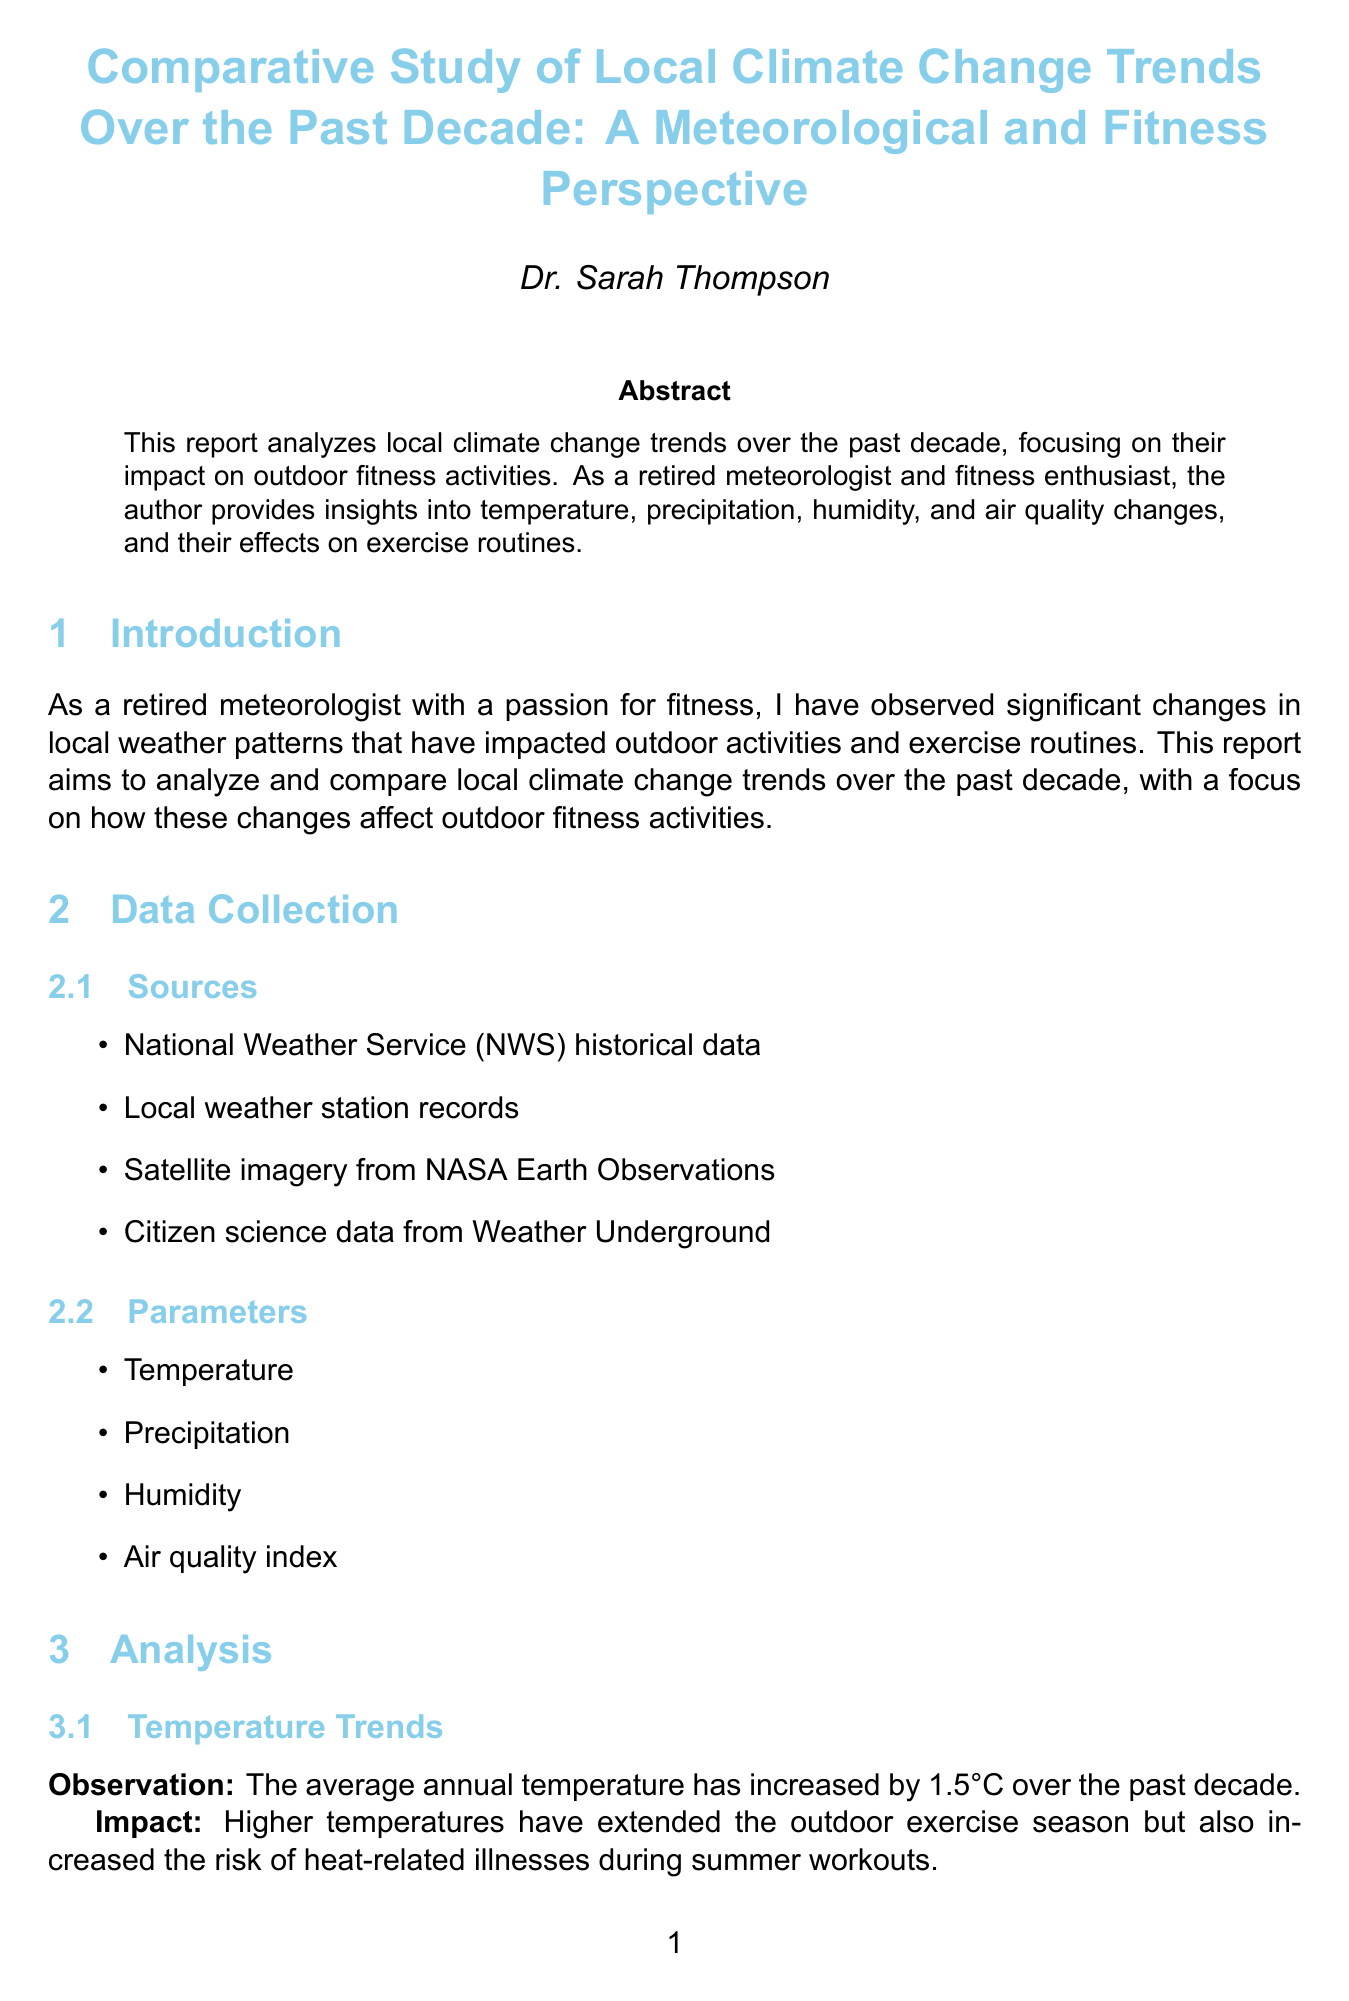what is the average annual temperature increase over the past decade? The report states that the average annual temperature has increased by 1.5°C over the past decade.
Answer: 1.5°C which year was noted for a spike in average annual temperatures? The report mentions a notable spike in average annual temperatures in the years 2016 and 2020.
Answer: 2016 and 2020 what data collection source is mentioned first? The sources for data collection are listed in a specific order, and the first one mentioned is National Weather Service (NWS) historical data.
Answer: National Weather Service (NWS) historical data what trend has been observed in summer humidity levels? The analysis section mentions that summer humidity levels have shown an upward trend, particularly in the early morning and late evening hours.
Answer: upward trend which recommendation is given for outdoor exercise timing? One recommendation states to encourage early morning or evening workouts to avoid peak temperatures.
Answer: early morning or evening workouts how many local case studies are presented in the report? The report lists two local case studies analyzing different impacts of climate change on outdoor activities.
Answer: two what is Dr. Sarah Thompson's professional background? The report describes Dr. Sarah Thompson as a retired meteorologist with 35 years of experience at the National Weather Service.
Answer: retired meteorologist what type of graphical representation shows average annual temperature trends? The graphical representation that shows average annual temperature trends is a line graph.
Answer: line graph what does the air quality index heat map display? The heat map displays daily air quality index values throughout the year.
Answer: daily air quality index values throughout the year 